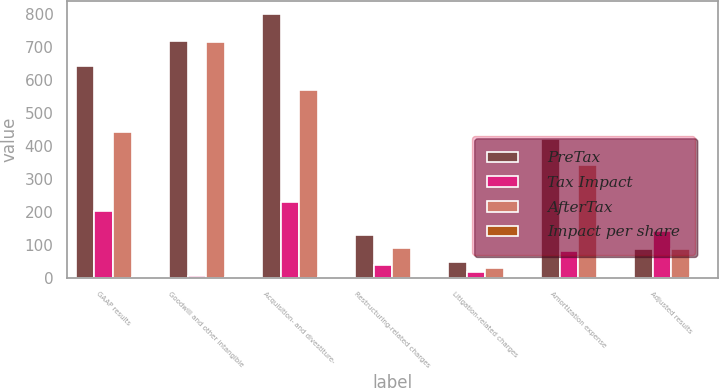Convert chart to OTSL. <chart><loc_0><loc_0><loc_500><loc_500><stacked_bar_chart><ecel><fcel>GAAP results<fcel>Goodwill and other intangible<fcel>Acquisition- and divestiture-<fcel>Restructuring-related charges<fcel>Litigation-related charges<fcel>Amortization expense<fcel>Adjusted results<nl><fcel>PreTax<fcel>642<fcel>718<fcel>798<fcel>129<fcel>48<fcel>421<fcel>85.5<nl><fcel>Tax Impact<fcel>201<fcel>5<fcel>229<fcel>39<fcel>18<fcel>81<fcel>142<nl><fcel>AfterTax<fcel>441<fcel>713<fcel>569<fcel>90<fcel>30<fcel>340<fcel>85.5<nl><fcel>Impact per share<fcel>0.29<fcel>0.47<fcel>0.37<fcel>0.06<fcel>0.02<fcel>0.22<fcel>0.67<nl></chart> 